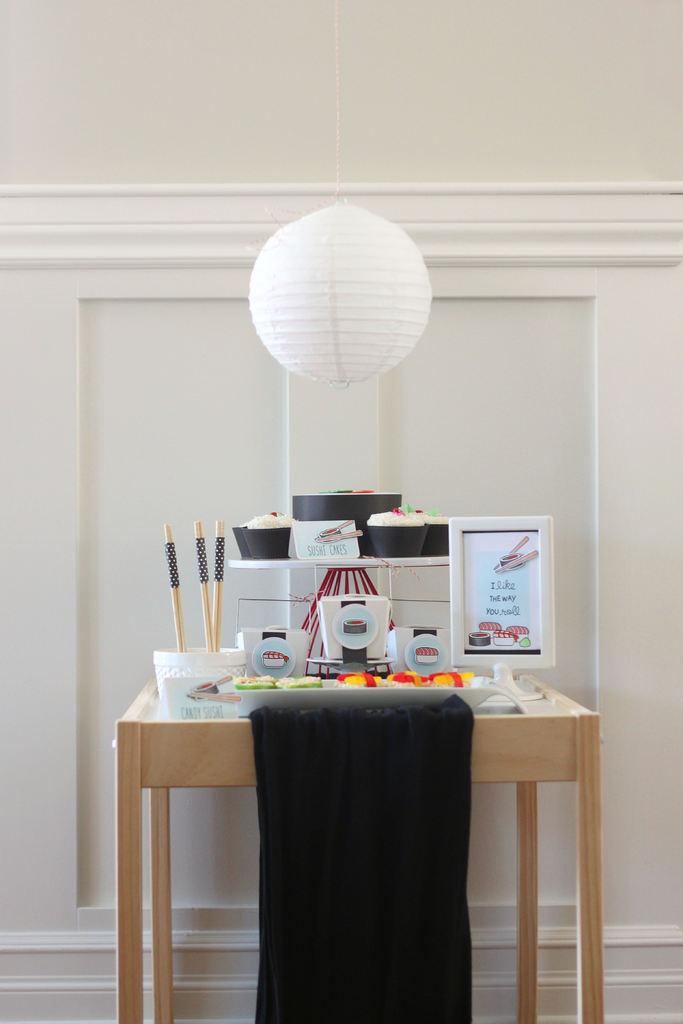Provide a one-sentence caption for the provided image. Next to the sushi on the table is a sign that says "I like the way you roll". 